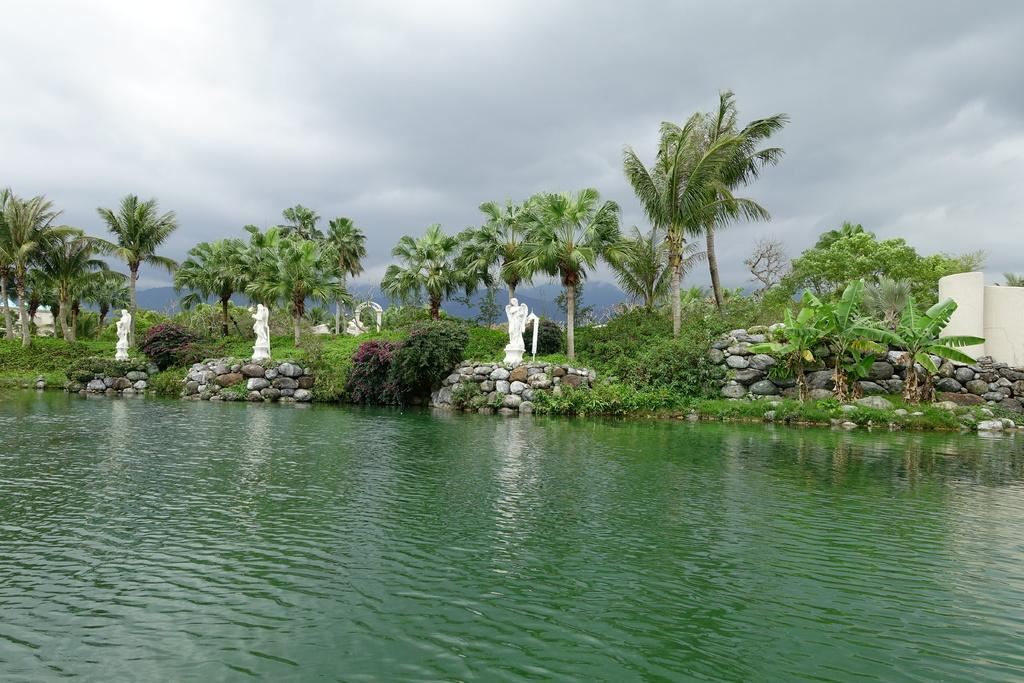What type of natural elements can be seen in the background of the image? There are many trees and plants in the background of the image. What type of structure is located in the front of the image? There is a stone fence in the front of the image. What can be found behind the stone fence? There are statues behind the stone fence. What is located in the front of the image, besides the stone fence? There is a pond in the front of the image. What is visible in the sky in the image? The sky is visible in the image, and clouds are present. How many legs can be seen on the statues in the image? There are no visible legs on the statues in the image, as statues typically do not have legs. 